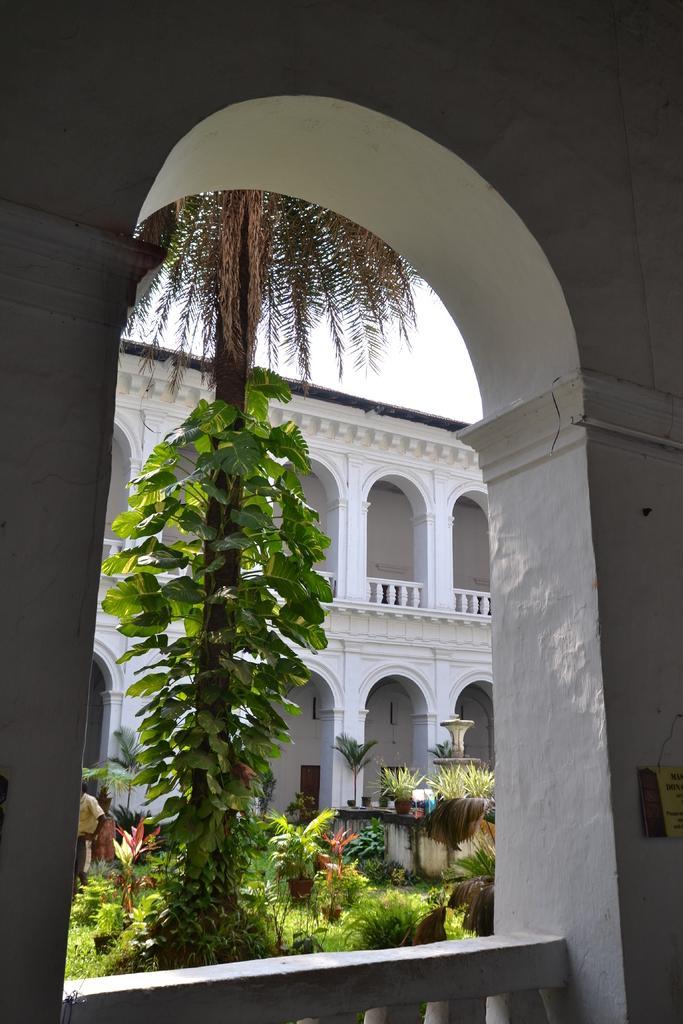Please provide a concise description of this image. In this image in the center there is a tree. In the front there is a balcony and there is an arch. In the background there is a building and there are plants and there is grass on the ground and there are persons visible. 